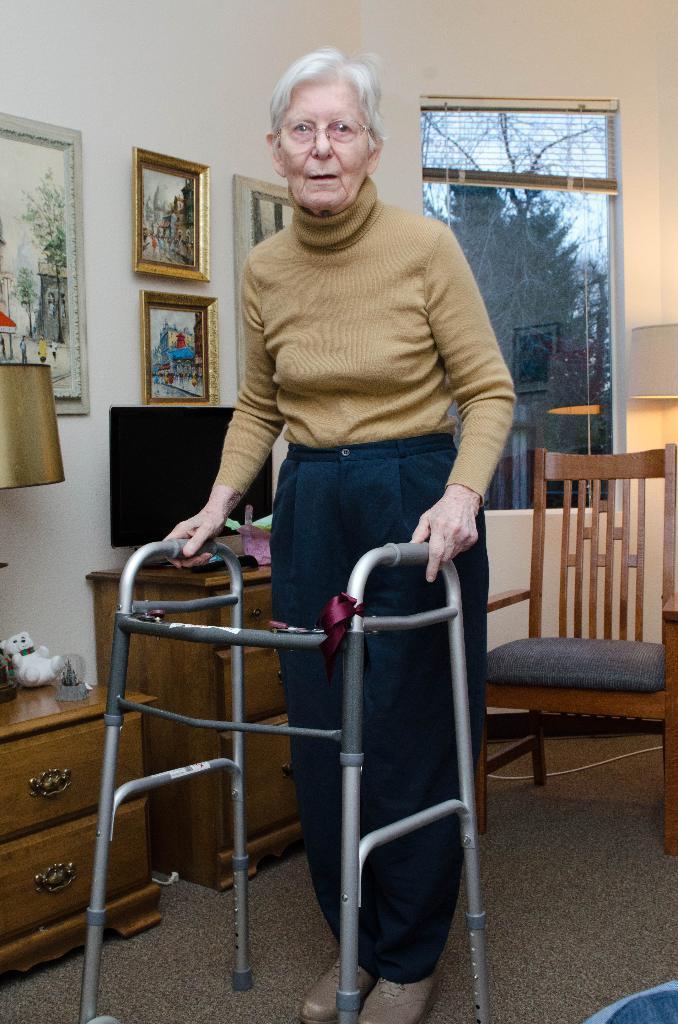Can you describe this image briefly? This picture shows a old woman standing with the help of a stand and in the backdrop there is a television this there is a window the wall of photo frames, there is a lamp. 